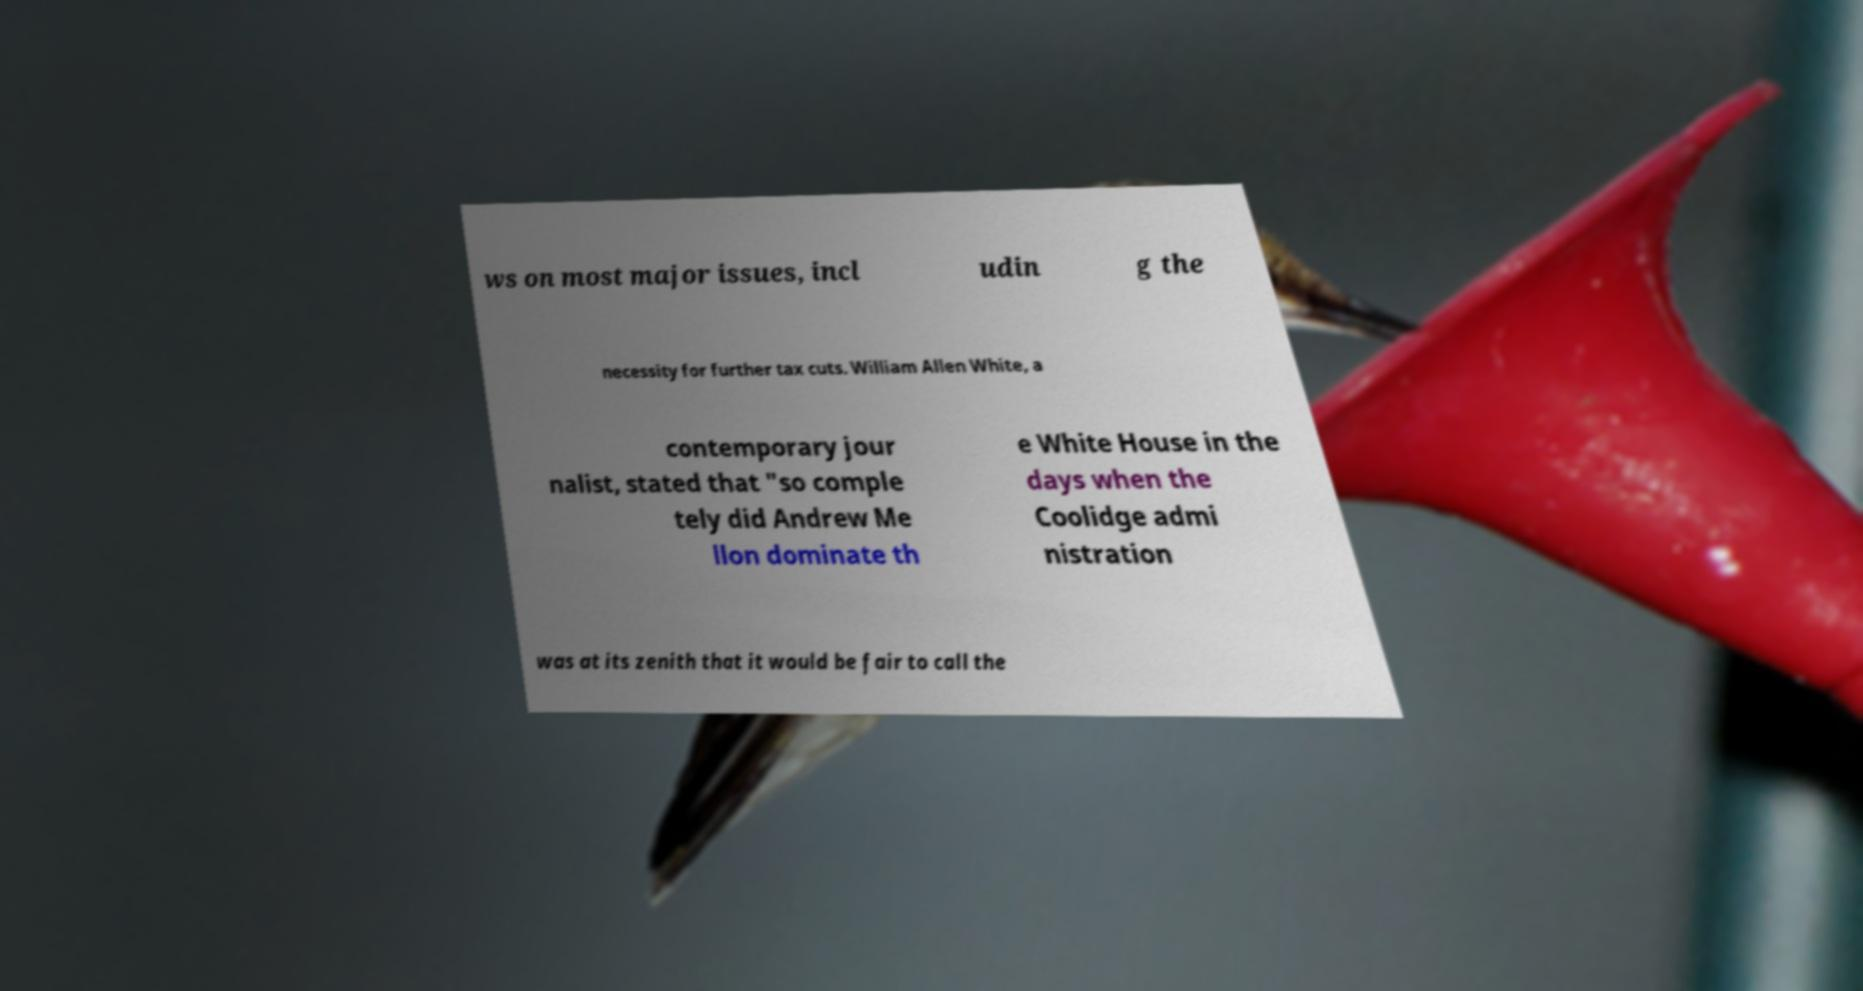For documentation purposes, I need the text within this image transcribed. Could you provide that? ws on most major issues, incl udin g the necessity for further tax cuts. William Allen White, a contemporary jour nalist, stated that "so comple tely did Andrew Me llon dominate th e White House in the days when the Coolidge admi nistration was at its zenith that it would be fair to call the 